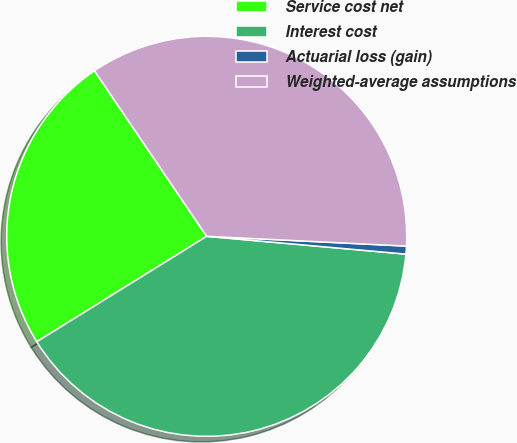Convert chart. <chart><loc_0><loc_0><loc_500><loc_500><pie_chart><fcel>Service cost net<fcel>Interest cost<fcel>Actuarial loss (gain)<fcel>Weighted-average assumptions<nl><fcel>24.36%<fcel>39.74%<fcel>0.64%<fcel>35.26%<nl></chart> 